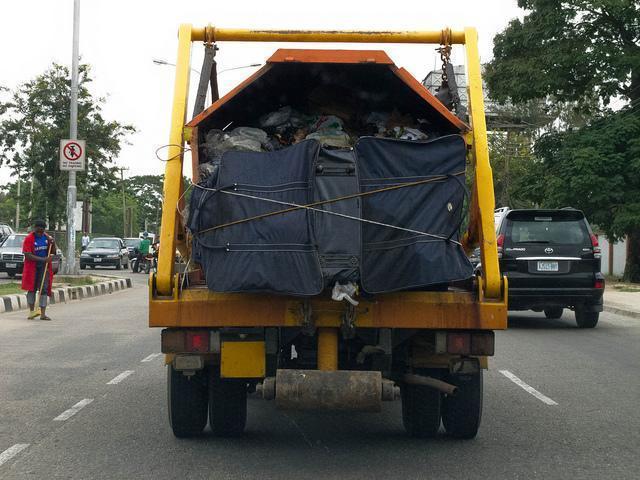Where might the truck in yellow be headed?
Choose the right answer and clarify with the format: 'Answer: answer
Rationale: rationale.'
Options: Car lot, home, junk yard, grocery store. Answer: junk yard.
Rationale: A truck is on the road and is full of garbage. 